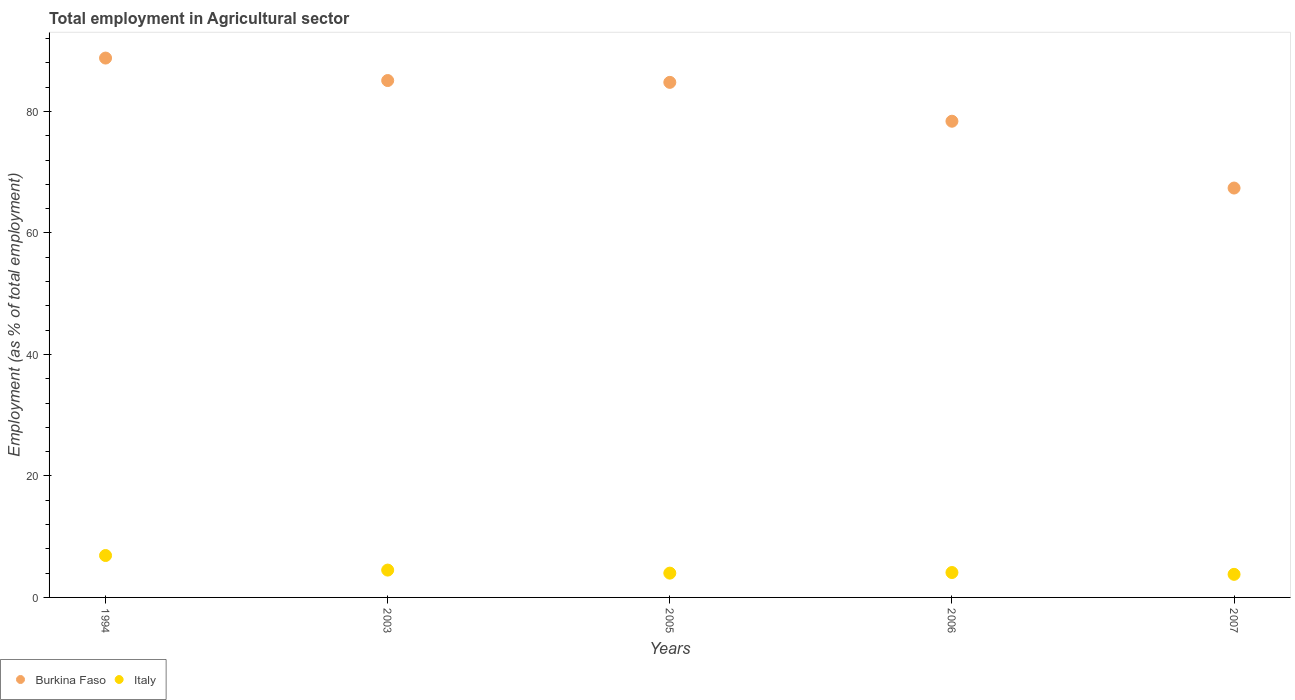Is the number of dotlines equal to the number of legend labels?
Offer a terse response. Yes. What is the employment in agricultural sector in Burkina Faso in 1994?
Keep it short and to the point. 88.8. Across all years, what is the maximum employment in agricultural sector in Italy?
Offer a very short reply. 6.9. Across all years, what is the minimum employment in agricultural sector in Burkina Faso?
Your response must be concise. 67.4. In which year was the employment in agricultural sector in Italy maximum?
Give a very brief answer. 1994. In which year was the employment in agricultural sector in Italy minimum?
Offer a terse response. 2007. What is the total employment in agricultural sector in Burkina Faso in the graph?
Your answer should be very brief. 404.5. What is the difference between the employment in agricultural sector in Italy in 2003 and that in 2007?
Ensure brevity in your answer.  0.7. What is the difference between the employment in agricultural sector in Italy in 1994 and the employment in agricultural sector in Burkina Faso in 2005?
Your answer should be very brief. -77.9. What is the average employment in agricultural sector in Burkina Faso per year?
Ensure brevity in your answer.  80.9. In the year 2007, what is the difference between the employment in agricultural sector in Burkina Faso and employment in agricultural sector in Italy?
Keep it short and to the point. 63.6. In how many years, is the employment in agricultural sector in Burkina Faso greater than 72 %?
Your answer should be compact. 4. What is the ratio of the employment in agricultural sector in Burkina Faso in 2005 to that in 2007?
Provide a succinct answer. 1.26. Is the difference between the employment in agricultural sector in Burkina Faso in 1994 and 2006 greater than the difference between the employment in agricultural sector in Italy in 1994 and 2006?
Make the answer very short. Yes. What is the difference between the highest and the second highest employment in agricultural sector in Italy?
Keep it short and to the point. 2.4. What is the difference between the highest and the lowest employment in agricultural sector in Italy?
Your response must be concise. 3.1. How many dotlines are there?
Ensure brevity in your answer.  2. How many legend labels are there?
Ensure brevity in your answer.  2. What is the title of the graph?
Make the answer very short. Total employment in Agricultural sector. Does "Ghana" appear as one of the legend labels in the graph?
Your answer should be compact. No. What is the label or title of the X-axis?
Make the answer very short. Years. What is the label or title of the Y-axis?
Provide a short and direct response. Employment (as % of total employment). What is the Employment (as % of total employment) of Burkina Faso in 1994?
Your answer should be compact. 88.8. What is the Employment (as % of total employment) in Italy in 1994?
Provide a succinct answer. 6.9. What is the Employment (as % of total employment) of Burkina Faso in 2003?
Make the answer very short. 85.1. What is the Employment (as % of total employment) in Burkina Faso in 2005?
Offer a very short reply. 84.8. What is the Employment (as % of total employment) of Burkina Faso in 2006?
Make the answer very short. 78.4. What is the Employment (as % of total employment) in Italy in 2006?
Your answer should be very brief. 4.1. What is the Employment (as % of total employment) in Burkina Faso in 2007?
Your answer should be compact. 67.4. What is the Employment (as % of total employment) in Italy in 2007?
Ensure brevity in your answer.  3.8. Across all years, what is the maximum Employment (as % of total employment) in Burkina Faso?
Keep it short and to the point. 88.8. Across all years, what is the maximum Employment (as % of total employment) in Italy?
Ensure brevity in your answer.  6.9. Across all years, what is the minimum Employment (as % of total employment) in Burkina Faso?
Make the answer very short. 67.4. Across all years, what is the minimum Employment (as % of total employment) in Italy?
Ensure brevity in your answer.  3.8. What is the total Employment (as % of total employment) in Burkina Faso in the graph?
Offer a terse response. 404.5. What is the total Employment (as % of total employment) in Italy in the graph?
Offer a terse response. 23.3. What is the difference between the Employment (as % of total employment) of Burkina Faso in 1994 and that in 2006?
Ensure brevity in your answer.  10.4. What is the difference between the Employment (as % of total employment) in Italy in 1994 and that in 2006?
Give a very brief answer. 2.8. What is the difference between the Employment (as % of total employment) of Burkina Faso in 1994 and that in 2007?
Offer a terse response. 21.4. What is the difference between the Employment (as % of total employment) in Italy in 1994 and that in 2007?
Make the answer very short. 3.1. What is the difference between the Employment (as % of total employment) of Burkina Faso in 2003 and that in 2005?
Your answer should be compact. 0.3. What is the difference between the Employment (as % of total employment) of Italy in 2003 and that in 2005?
Your response must be concise. 0.5. What is the difference between the Employment (as % of total employment) in Italy in 2003 and that in 2006?
Make the answer very short. 0.4. What is the difference between the Employment (as % of total employment) in Burkina Faso in 2005 and that in 2006?
Offer a terse response. 6.4. What is the difference between the Employment (as % of total employment) in Italy in 2005 and that in 2006?
Your response must be concise. -0.1. What is the difference between the Employment (as % of total employment) of Italy in 2006 and that in 2007?
Make the answer very short. 0.3. What is the difference between the Employment (as % of total employment) of Burkina Faso in 1994 and the Employment (as % of total employment) of Italy in 2003?
Offer a very short reply. 84.3. What is the difference between the Employment (as % of total employment) of Burkina Faso in 1994 and the Employment (as % of total employment) of Italy in 2005?
Ensure brevity in your answer.  84.8. What is the difference between the Employment (as % of total employment) in Burkina Faso in 1994 and the Employment (as % of total employment) in Italy in 2006?
Your answer should be very brief. 84.7. What is the difference between the Employment (as % of total employment) in Burkina Faso in 1994 and the Employment (as % of total employment) in Italy in 2007?
Keep it short and to the point. 85. What is the difference between the Employment (as % of total employment) in Burkina Faso in 2003 and the Employment (as % of total employment) in Italy in 2005?
Offer a terse response. 81.1. What is the difference between the Employment (as % of total employment) in Burkina Faso in 2003 and the Employment (as % of total employment) in Italy in 2006?
Give a very brief answer. 81. What is the difference between the Employment (as % of total employment) of Burkina Faso in 2003 and the Employment (as % of total employment) of Italy in 2007?
Offer a very short reply. 81.3. What is the difference between the Employment (as % of total employment) in Burkina Faso in 2005 and the Employment (as % of total employment) in Italy in 2006?
Give a very brief answer. 80.7. What is the difference between the Employment (as % of total employment) in Burkina Faso in 2006 and the Employment (as % of total employment) in Italy in 2007?
Keep it short and to the point. 74.6. What is the average Employment (as % of total employment) in Burkina Faso per year?
Offer a terse response. 80.9. What is the average Employment (as % of total employment) of Italy per year?
Make the answer very short. 4.66. In the year 1994, what is the difference between the Employment (as % of total employment) in Burkina Faso and Employment (as % of total employment) in Italy?
Your answer should be compact. 81.9. In the year 2003, what is the difference between the Employment (as % of total employment) in Burkina Faso and Employment (as % of total employment) in Italy?
Offer a terse response. 80.6. In the year 2005, what is the difference between the Employment (as % of total employment) in Burkina Faso and Employment (as % of total employment) in Italy?
Your answer should be compact. 80.8. In the year 2006, what is the difference between the Employment (as % of total employment) of Burkina Faso and Employment (as % of total employment) of Italy?
Your response must be concise. 74.3. In the year 2007, what is the difference between the Employment (as % of total employment) of Burkina Faso and Employment (as % of total employment) of Italy?
Your answer should be very brief. 63.6. What is the ratio of the Employment (as % of total employment) in Burkina Faso in 1994 to that in 2003?
Provide a short and direct response. 1.04. What is the ratio of the Employment (as % of total employment) of Italy in 1994 to that in 2003?
Make the answer very short. 1.53. What is the ratio of the Employment (as % of total employment) in Burkina Faso in 1994 to that in 2005?
Ensure brevity in your answer.  1.05. What is the ratio of the Employment (as % of total employment) in Italy in 1994 to that in 2005?
Make the answer very short. 1.73. What is the ratio of the Employment (as % of total employment) in Burkina Faso in 1994 to that in 2006?
Provide a succinct answer. 1.13. What is the ratio of the Employment (as % of total employment) in Italy in 1994 to that in 2006?
Offer a terse response. 1.68. What is the ratio of the Employment (as % of total employment) in Burkina Faso in 1994 to that in 2007?
Provide a short and direct response. 1.32. What is the ratio of the Employment (as % of total employment) of Italy in 1994 to that in 2007?
Give a very brief answer. 1.82. What is the ratio of the Employment (as % of total employment) in Italy in 2003 to that in 2005?
Your answer should be very brief. 1.12. What is the ratio of the Employment (as % of total employment) in Burkina Faso in 2003 to that in 2006?
Make the answer very short. 1.09. What is the ratio of the Employment (as % of total employment) in Italy in 2003 to that in 2006?
Your response must be concise. 1.1. What is the ratio of the Employment (as % of total employment) of Burkina Faso in 2003 to that in 2007?
Ensure brevity in your answer.  1.26. What is the ratio of the Employment (as % of total employment) in Italy in 2003 to that in 2007?
Make the answer very short. 1.18. What is the ratio of the Employment (as % of total employment) in Burkina Faso in 2005 to that in 2006?
Your answer should be compact. 1.08. What is the ratio of the Employment (as % of total employment) of Italy in 2005 to that in 2006?
Offer a very short reply. 0.98. What is the ratio of the Employment (as % of total employment) of Burkina Faso in 2005 to that in 2007?
Your answer should be compact. 1.26. What is the ratio of the Employment (as % of total employment) of Italy in 2005 to that in 2007?
Provide a short and direct response. 1.05. What is the ratio of the Employment (as % of total employment) of Burkina Faso in 2006 to that in 2007?
Provide a succinct answer. 1.16. What is the ratio of the Employment (as % of total employment) of Italy in 2006 to that in 2007?
Provide a succinct answer. 1.08. What is the difference between the highest and the second highest Employment (as % of total employment) of Italy?
Give a very brief answer. 2.4. What is the difference between the highest and the lowest Employment (as % of total employment) in Burkina Faso?
Keep it short and to the point. 21.4. What is the difference between the highest and the lowest Employment (as % of total employment) in Italy?
Offer a terse response. 3.1. 